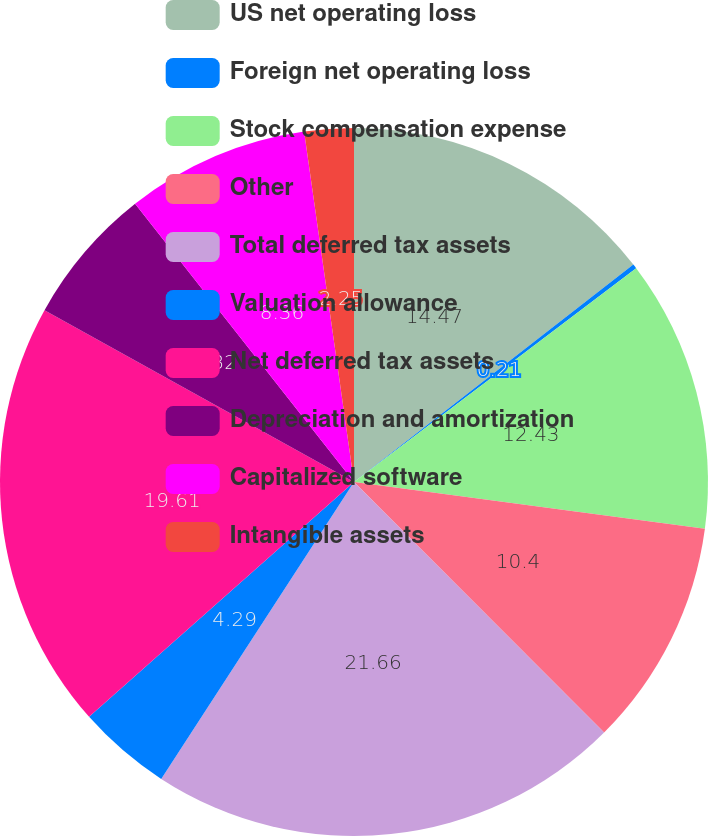Convert chart to OTSL. <chart><loc_0><loc_0><loc_500><loc_500><pie_chart><fcel>US net operating loss<fcel>Foreign net operating loss<fcel>Stock compensation expense<fcel>Other<fcel>Total deferred tax assets<fcel>Valuation allowance<fcel>Net deferred tax assets<fcel>Depreciation and amortization<fcel>Capitalized software<fcel>Intangible assets<nl><fcel>14.47%<fcel>0.21%<fcel>12.43%<fcel>10.4%<fcel>21.65%<fcel>4.29%<fcel>19.61%<fcel>6.32%<fcel>8.36%<fcel>2.25%<nl></chart> 